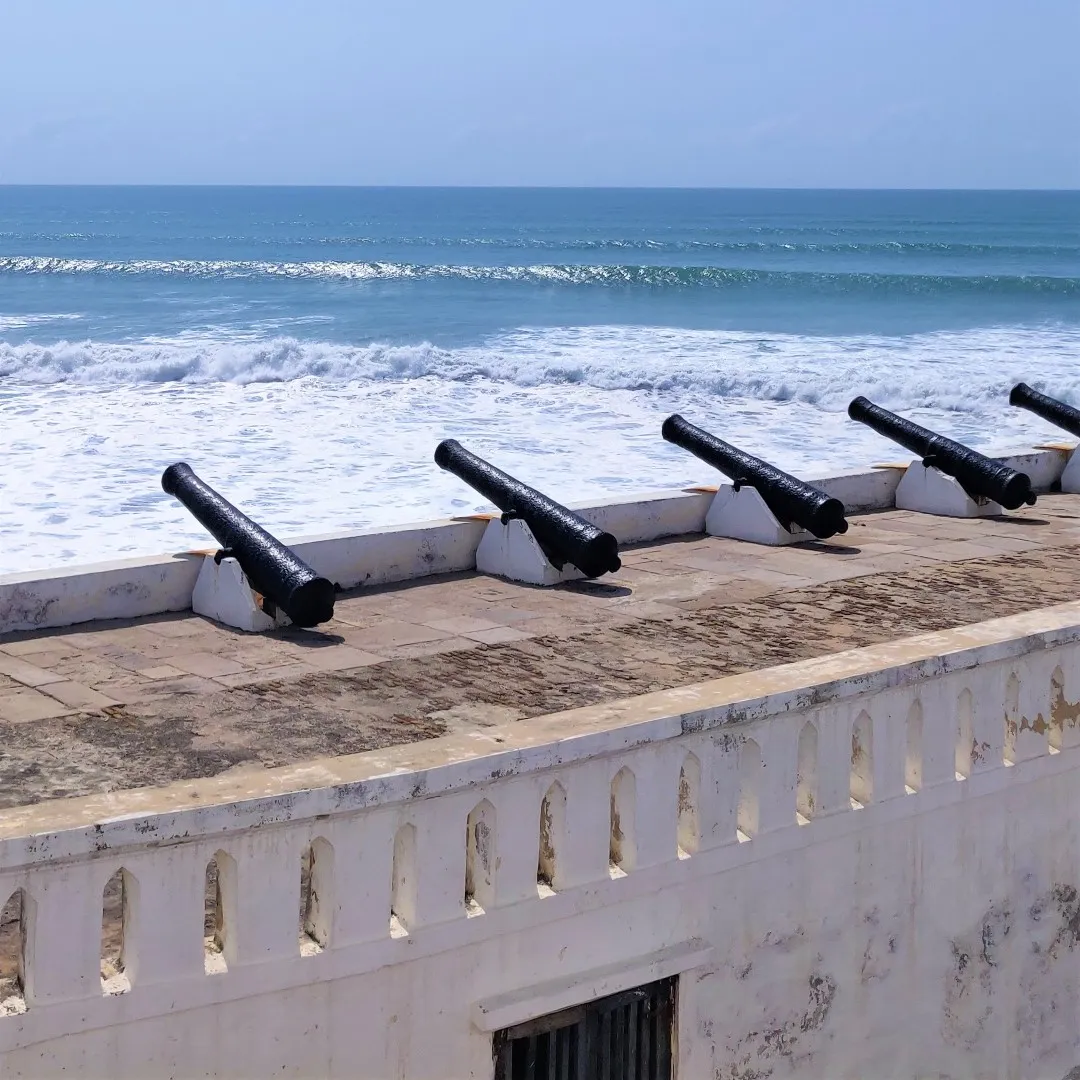How might the fort look during a stormy night? During a stormy night, the fort along the Cape Coast would transform into a dramatic and foreboding scene. The sky, shrouded in heavy, dark clouds, occasionally illuminated by sharp flashes of lightning, casts an eerie glow over the landscape. The once clear and tranquil ocean is now a tumultuous expanse of frothing waves, crashing relentlessly against the shore and fort walls with a deafening roar. The cannons, slick with rainwater, glisten under the sporadic lighting, appearing both menacing and majestic. The howling wind sweeps through the open spaces, carrying with it the smell of salt and the somber echoes of history. The white walls of the fort, drenched and glistening in the murky light, stand stark against the backdrop of the violent storm. Amidst the chaos, the fort remains an immovable sentinel, its ancient stones bearing silent witness to the fury of nature and the passage of centuries. It is a moment of raw, untamed beauty where the storm seems to bring the history etched in the fort's walls to life, a reminder of the fort's enduring strength and resilience. Describe a serene early morning at the fort. In the tranquil stillness of an early morning at the fort, the world awakens slowly. The first rays of the sun creep over the horizon, casting a golden hue across the landscape. The ocean, now gentle and calm, laps softly against the shore, its surface reflecting the soft pastel colors of dawn. A light mist hovers over the water, adding a dreamlike quality to the scene. The cannons, standing silent and dormant, are bathed in the warm glow of the rising sun, their dark silhouettes sharp against the pale light. The fort's white walls, kissed by the gentle morning light, seem almost to glow, their weathered surfaces holding the tranquility of the moment. Seabirds begin their morning calls, the sound blending with the rhythmic lapping of the waves. The air is fresh and cool, filled with the promise of a new day. As the sun rises higher, the shadows retreat, and the fort stands proudly, a timeless guardian of the coast, embracing the serene beauty of dawn with a quiet dignity. 